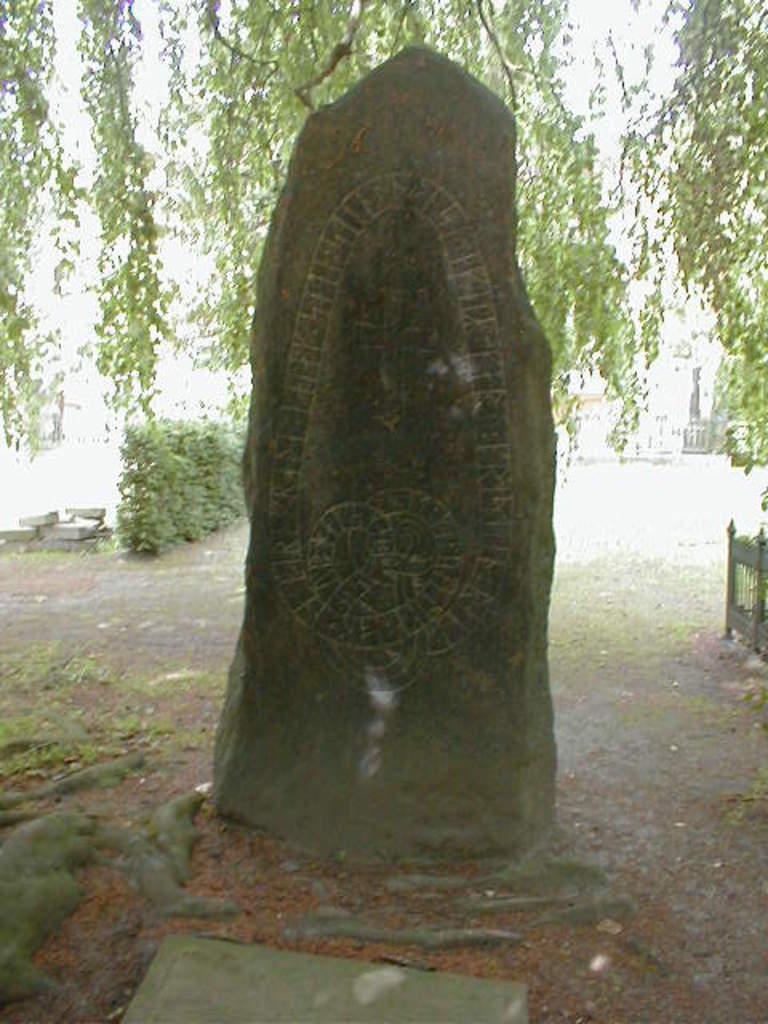Describe this image in one or two sentences. In the center of the image, we can see a stone and in the background, there are trees, a railing and there are plants. At the bottom, there is ground. 